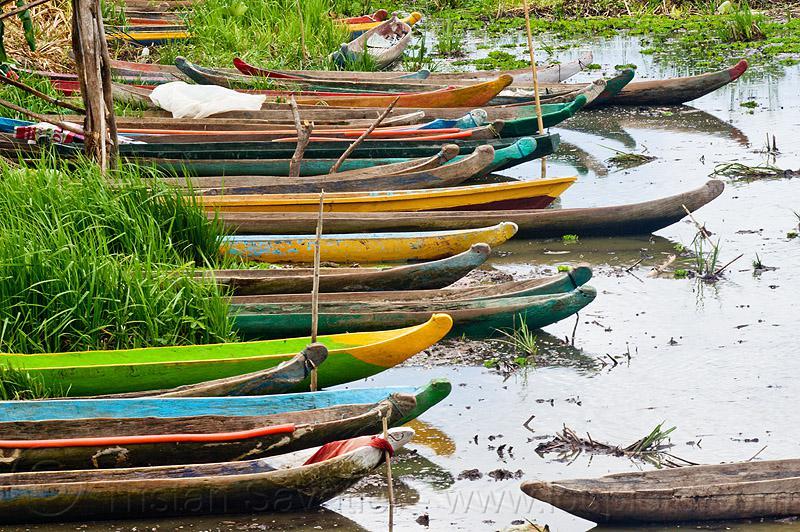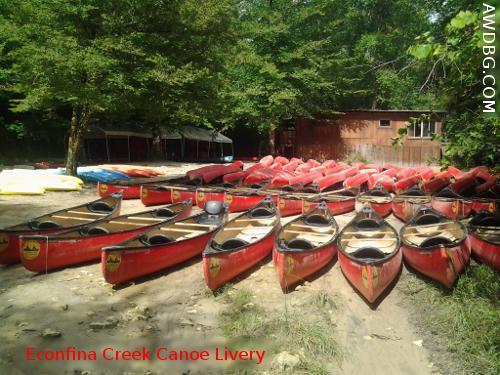The first image is the image on the left, the second image is the image on the right. Evaluate the accuracy of this statement regarding the images: "There is a woman in the image on the right.". Is it true? Answer yes or no. No. 